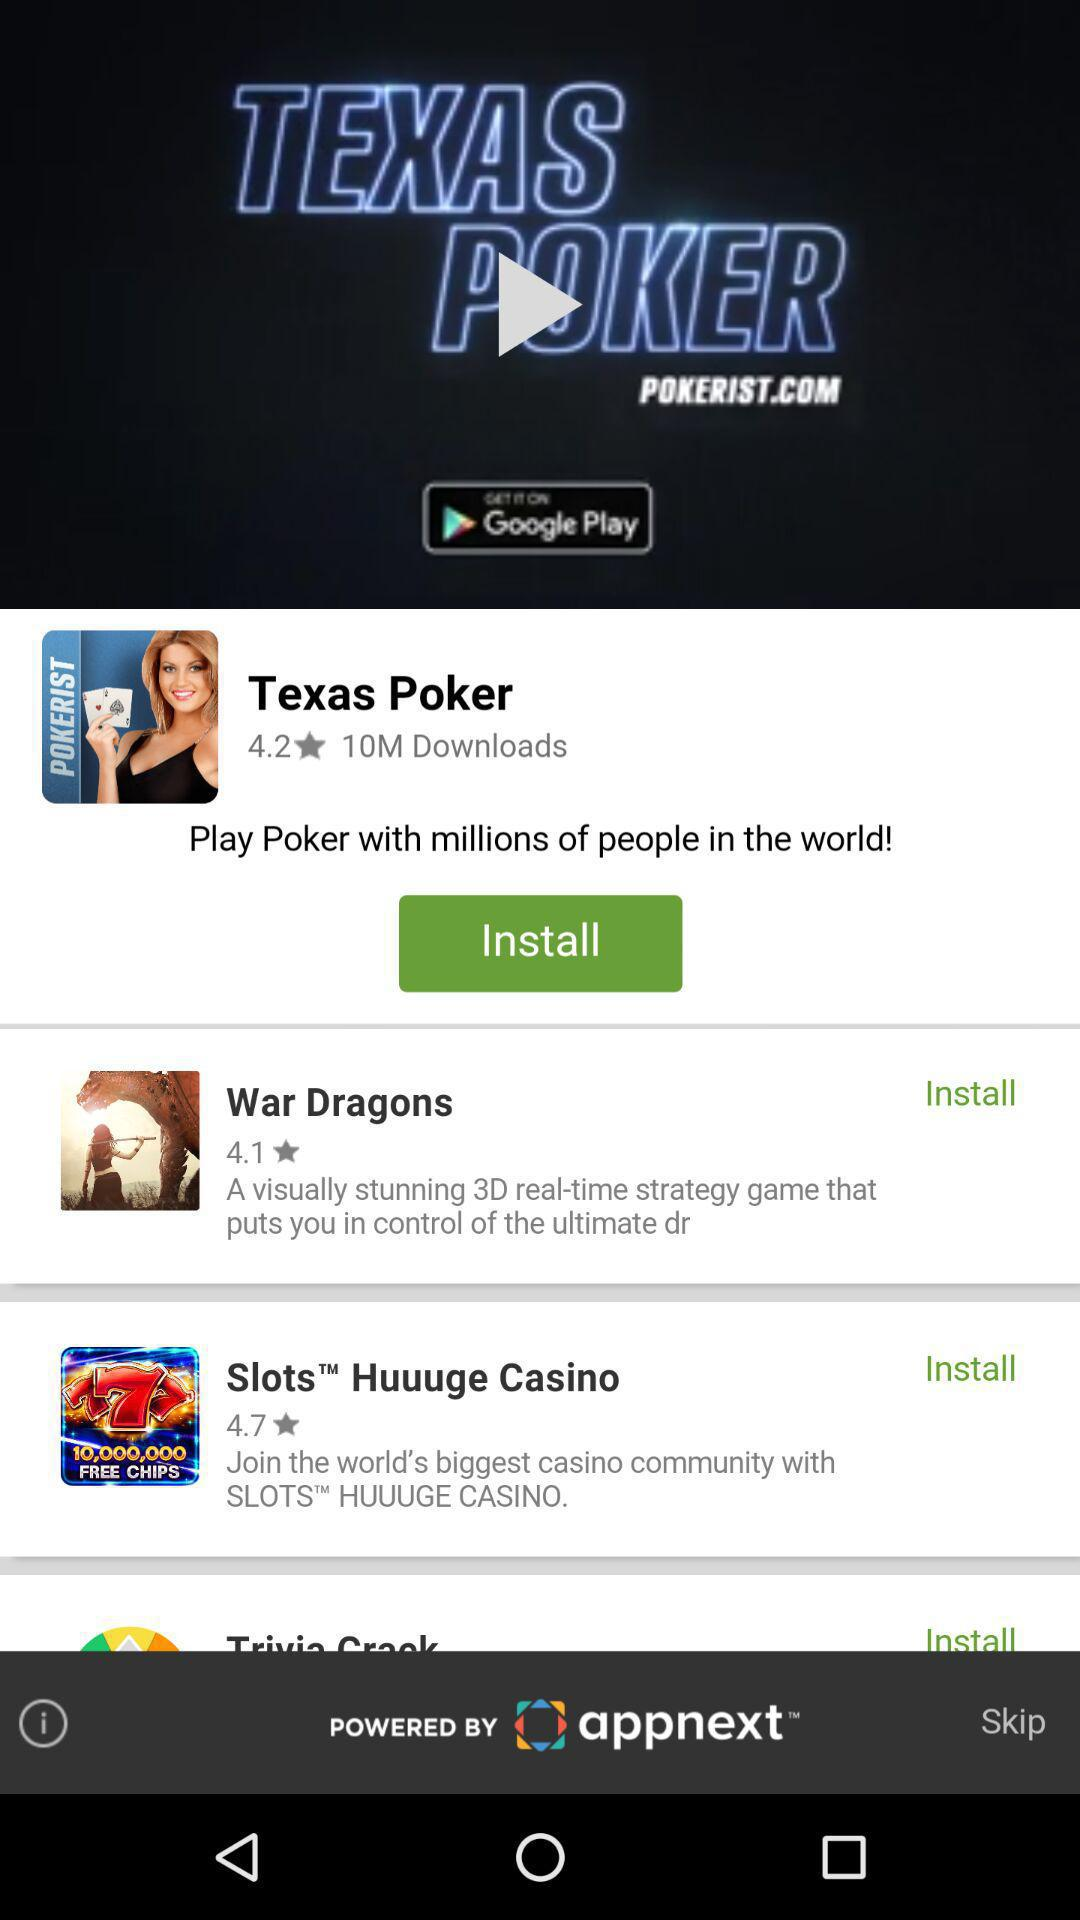How many games have a rating of 4.0 or higher?
Answer the question using a single word or phrase. 3 